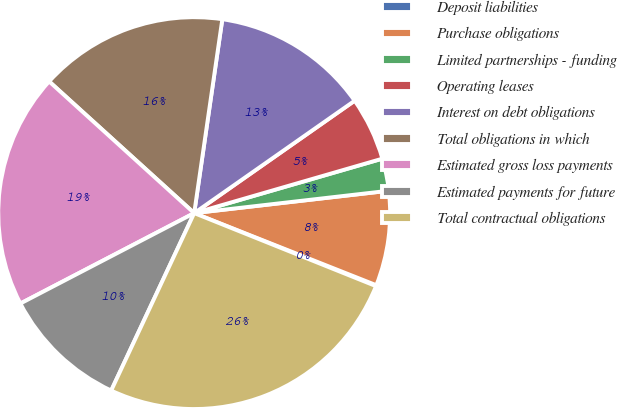Convert chart to OTSL. <chart><loc_0><loc_0><loc_500><loc_500><pie_chart><fcel>Deposit liabilities<fcel>Purchase obligations<fcel>Limited partnerships - funding<fcel>Operating leases<fcel>Interest on debt obligations<fcel>Total obligations in which<fcel>Estimated gross loss payments<fcel>Estimated payments for future<fcel>Total contractual obligations<nl><fcel>0.08%<fcel>7.82%<fcel>2.66%<fcel>5.24%<fcel>12.98%<fcel>15.56%<fcel>19.36%<fcel>10.4%<fcel>25.88%<nl></chart> 